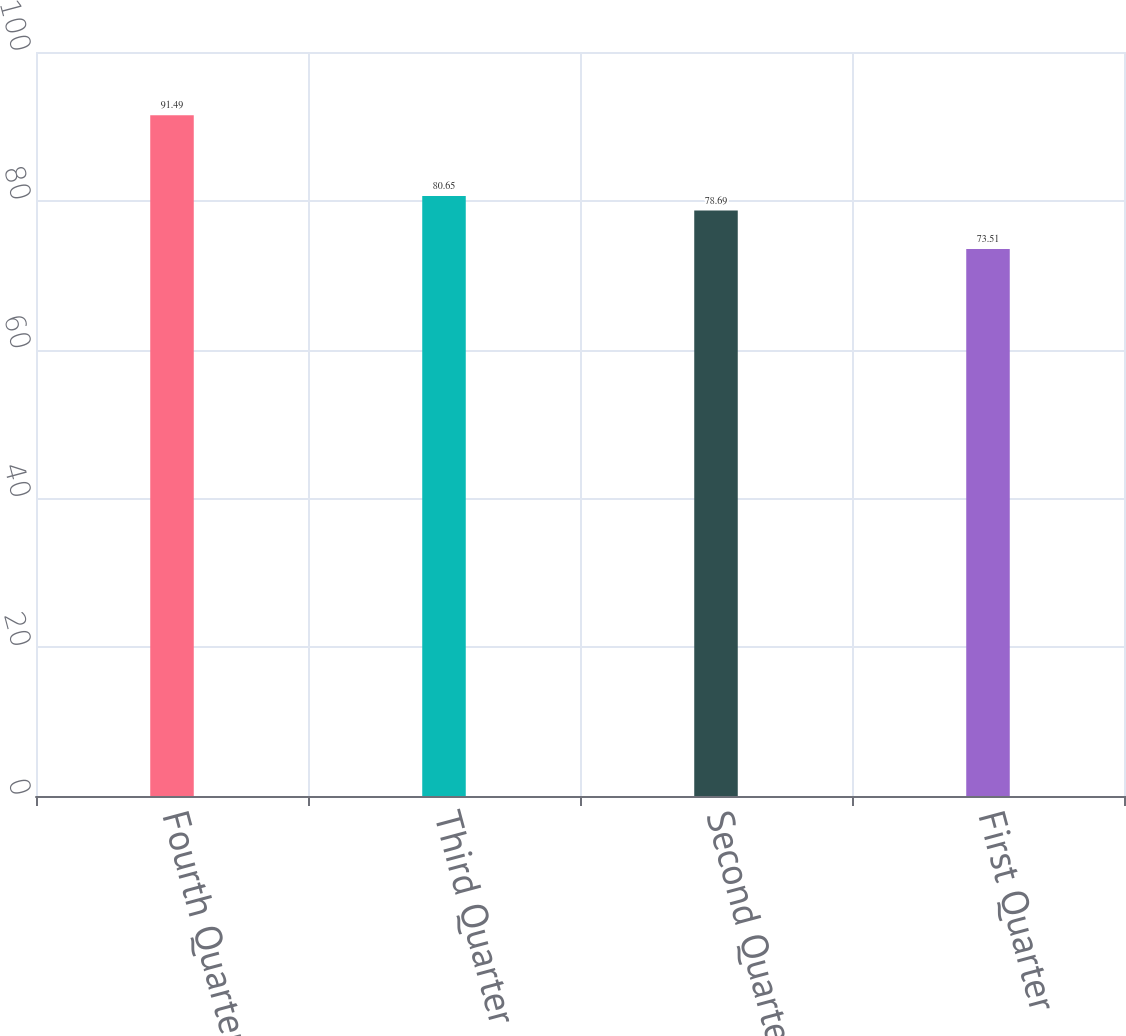Convert chart. <chart><loc_0><loc_0><loc_500><loc_500><bar_chart><fcel>Fourth Quarter<fcel>Third Quarter<fcel>Second Quarter<fcel>First Quarter<nl><fcel>91.49<fcel>80.65<fcel>78.69<fcel>73.51<nl></chart> 